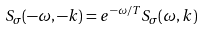Convert formula to latex. <formula><loc_0><loc_0><loc_500><loc_500>S _ { \sigma } ( - \omega , - { k } ) = e ^ { - \omega / T } S _ { \sigma } ( \omega , { k } )</formula> 